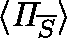Convert formula to latex. <formula><loc_0><loc_0><loc_500><loc_500>\langle \Pi _ { \overline { S } } \rangle</formula> 